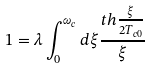<formula> <loc_0><loc_0><loc_500><loc_500>1 = \lambda \int _ { 0 } ^ { \omega _ { c } } d \xi \frac { t h \frac { \xi } { 2 T _ { c 0 } } } { \xi }</formula> 